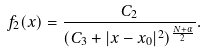<formula> <loc_0><loc_0><loc_500><loc_500>f _ { 2 } ( x ) = \frac { C _ { 2 } } { ( C _ { 3 } + | x - x _ { 0 } | ^ { 2 } ) ^ { \frac { N + \alpha } { 2 } } } .</formula> 